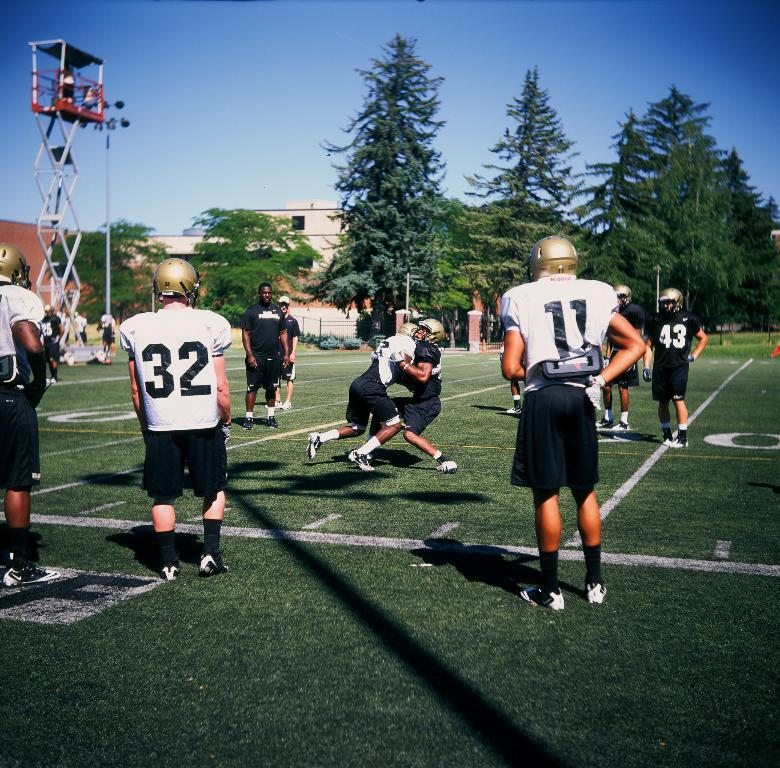What colors are the dresses of the people in the image? The people in the image are wearing black and white color dresses. What protective gear are the people wearing? The people are wearing helmets. What type of vegetation can be seen in the image? There are trees in the image. What type of structures are present in the image? Light-poles and a building are present in the image. What is visible in the sky in the image? The sky is visible in the image. What equipment is present in the image for working at heights? An electric ladder is present in the image. Are there any children attending the party in the image? There is no party or children present in the image. 